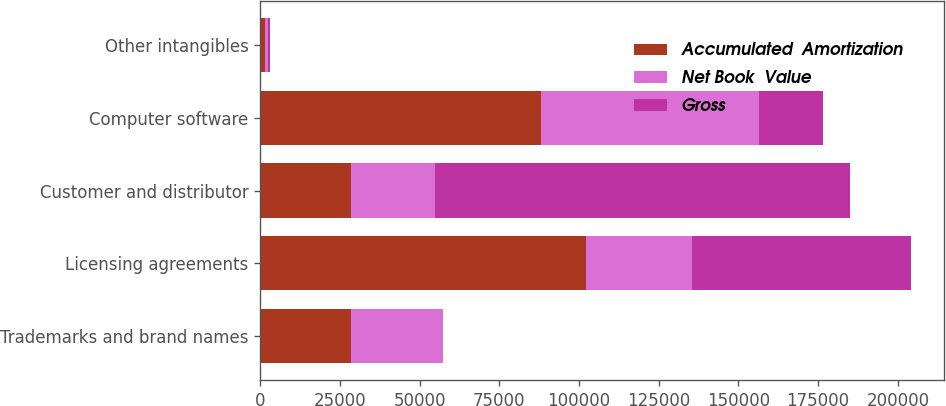<chart> <loc_0><loc_0><loc_500><loc_500><stacked_bar_chart><ecel><fcel>Trademarks and brand names<fcel>Licensing agreements<fcel>Customer and distributor<fcel>Computer software<fcel>Other intangibles<nl><fcel>Accumulated  Amortization<fcel>28617<fcel>102069<fcel>28612<fcel>88213<fcel>1498<nl><fcel>Net Book  Value<fcel>28607<fcel>33397<fcel>26153<fcel>68318<fcel>994<nl><fcel>Gross<fcel>10<fcel>68672<fcel>130187<fcel>19895<fcel>504<nl></chart> 